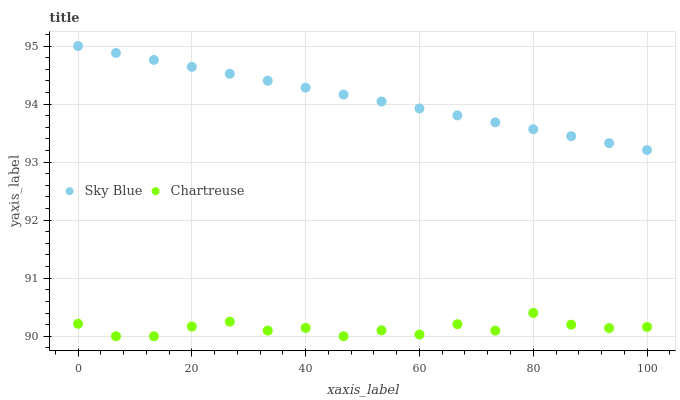Does Chartreuse have the minimum area under the curve?
Answer yes or no. Yes. Does Sky Blue have the maximum area under the curve?
Answer yes or no. Yes. Does Chartreuse have the maximum area under the curve?
Answer yes or no. No. Is Sky Blue the smoothest?
Answer yes or no. Yes. Is Chartreuse the roughest?
Answer yes or no. Yes. Is Chartreuse the smoothest?
Answer yes or no. No. Does Chartreuse have the lowest value?
Answer yes or no. Yes. Does Sky Blue have the highest value?
Answer yes or no. Yes. Does Chartreuse have the highest value?
Answer yes or no. No. Is Chartreuse less than Sky Blue?
Answer yes or no. Yes. Is Sky Blue greater than Chartreuse?
Answer yes or no. Yes. Does Chartreuse intersect Sky Blue?
Answer yes or no. No. 